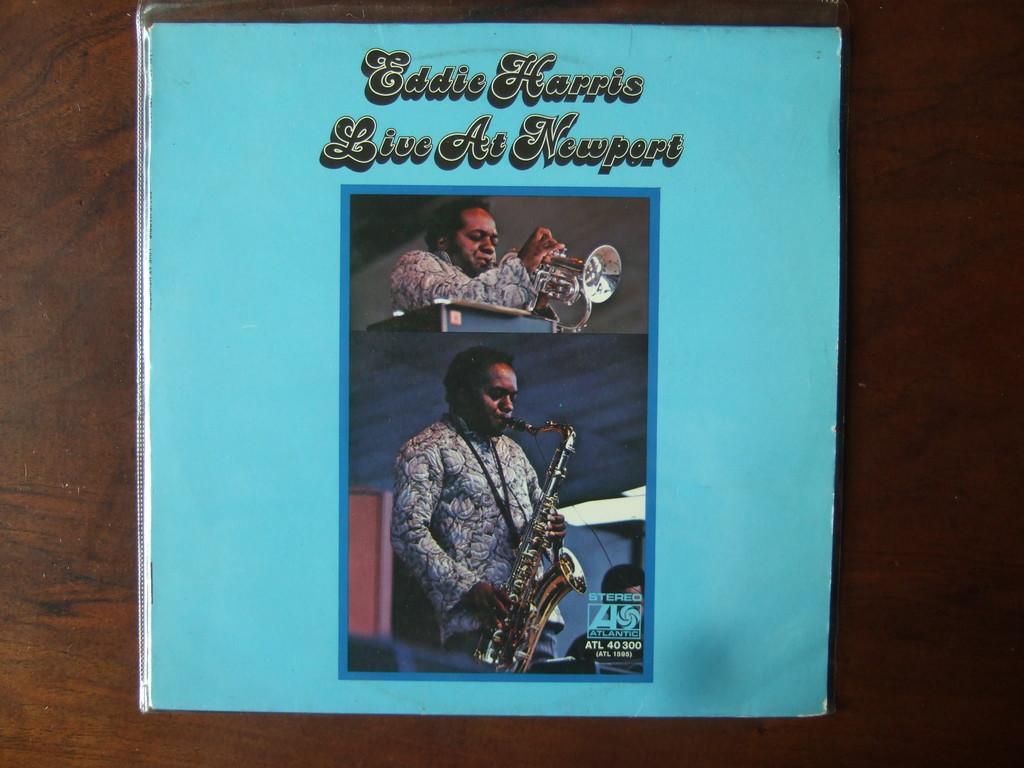What is the name of the event?
Offer a very short reply. Live at newport. 